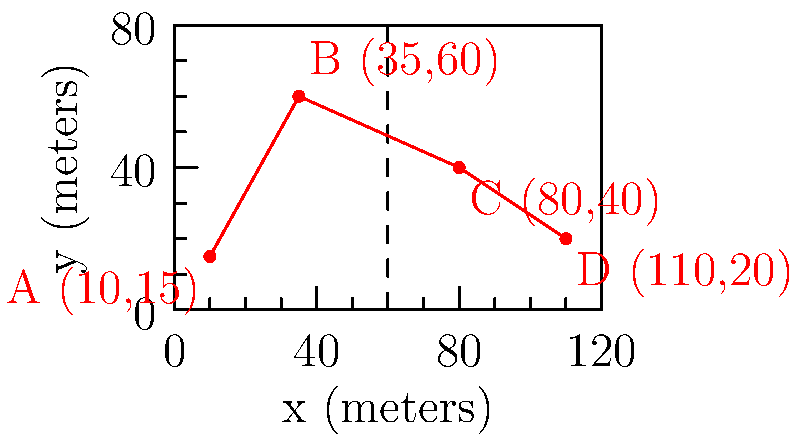A young talent from the Scottish Championship is being closely monitored during a match. His movements are tracked on a coordinate system representing the pitch, where each unit represents 1 meter. The player's key positions during the match are recorded as A(10,15), B(35,60), C(80,40), and D(110,20), in that order. Calculate the total distance covered by the player between these points, rounded to the nearest meter. To solve this problem, we need to calculate the distance between consecutive points and sum them up. We'll use the distance formula between two points: $d = \sqrt{(x_2-x_1)^2 + (y_2-y_1)^2}$

Step 1: Calculate distance from A to B
$d_{AB} = \sqrt{(35-10)^2 + (60-15)^2} = \sqrt{25^2 + 45^2} = \sqrt{2650} \approx 51.48$ meters

Step 2: Calculate distance from B to C
$d_{BC} = \sqrt{(80-35)^2 + (40-60)^2} = \sqrt{45^2 + (-20)^2} = \sqrt{2425} \approx 49.24$ meters

Step 3: Calculate distance from C to D
$d_{CD} = \sqrt{(110-80)^2 + (20-40)^2} = \sqrt{30^2 + (-20)^2} = \sqrt{1300} \approx 36.06$ meters

Step 4: Sum up all distances
Total distance = $d_{AB} + d_{BC} + d_{CD} = 51.48 + 49.24 + 36.06 = 136.78$ meters

Step 5: Round to the nearest meter
136.78 rounds to 137 meters
Answer: 137 meters 